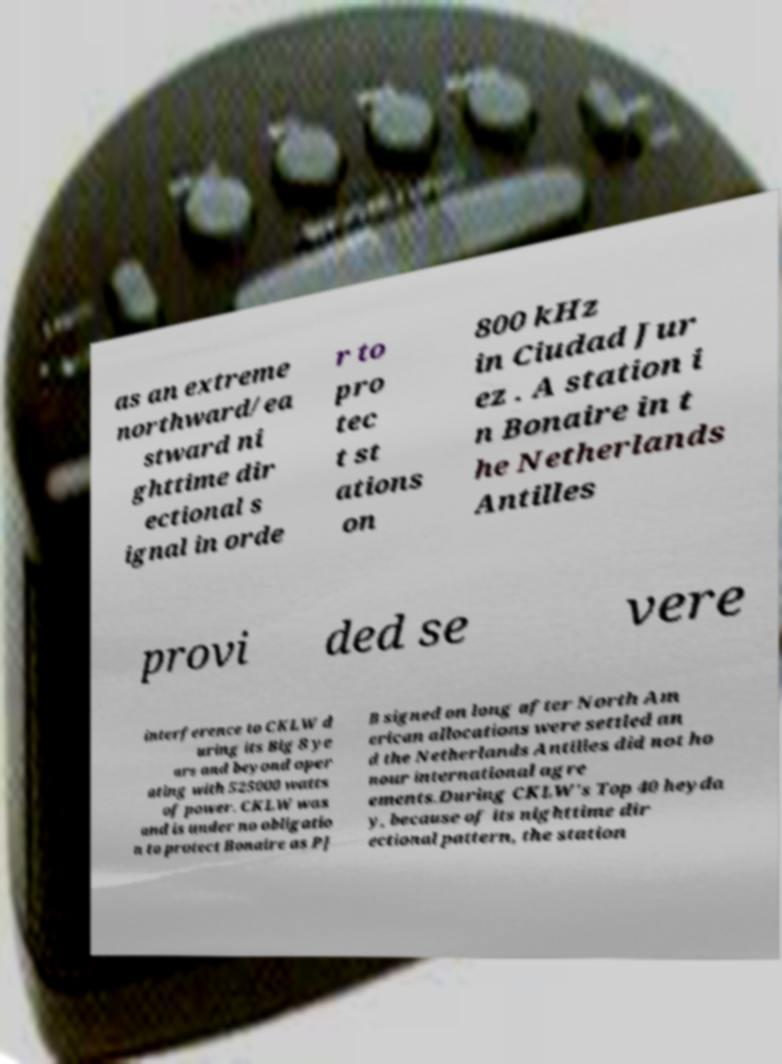There's text embedded in this image that I need extracted. Can you transcribe it verbatim? as an extreme northward/ea stward ni ghttime dir ectional s ignal in orde r to pro tec t st ations on 800 kHz in Ciudad Jur ez . A station i n Bonaire in t he Netherlands Antilles provi ded se vere interference to CKLW d uring its Big 8 ye ars and beyond oper ating with 525000 watts of power. CKLW was and is under no obligatio n to protect Bonaire as PJ B signed on long after North Am erican allocations were settled an d the Netherlands Antilles did not ho nour international agre ements.During CKLW's Top 40 heyda y, because of its nighttime dir ectional pattern, the station 